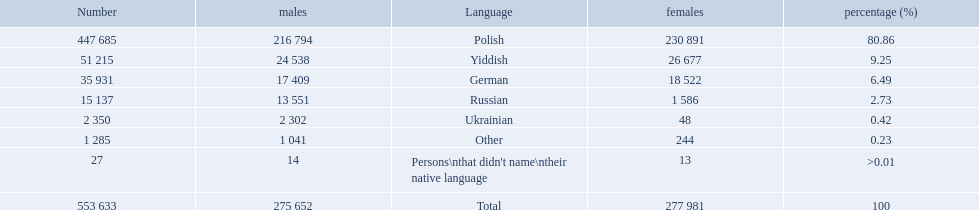What are all of the languages? Polish, Yiddish, German, Russian, Ukrainian, Other, Persons\nthat didn't name\ntheir native language. And how many people speak these languages? 447 685, 51 215, 35 931, 15 137, 2 350, 1 285, 27. Which language is used by most people? Polish. Which language options are listed? Polish, Yiddish, German, Russian, Ukrainian, Other, Persons\nthat didn't name\ntheir native language. Of these, which did .42% of the people select? Ukrainian. Could you help me parse every detail presented in this table? {'header': ['Number', 'males', 'Language', 'females', 'percentage (%)'], 'rows': [['447 685', '216 794', 'Polish', '230 891', '80.86'], ['51 215', '24 538', 'Yiddish', '26 677', '9.25'], ['35 931', '17 409', 'German', '18 522', '6.49'], ['15 137', '13 551', 'Russian', '1 586', '2.73'], ['2 350', '2 302', 'Ukrainian', '48', '0.42'], ['1 285', '1 041', 'Other', '244', '0.23'], ['27', '14', "Persons\\nthat didn't name\\ntheir native language", '13', '>0.01'], ['553 633', '275 652', 'Total', '277 981', '100']]} What was the highest percentage of one language spoken by the plock governorate? 80.86. What language was spoken by 80.86 percent of the people? Polish. 